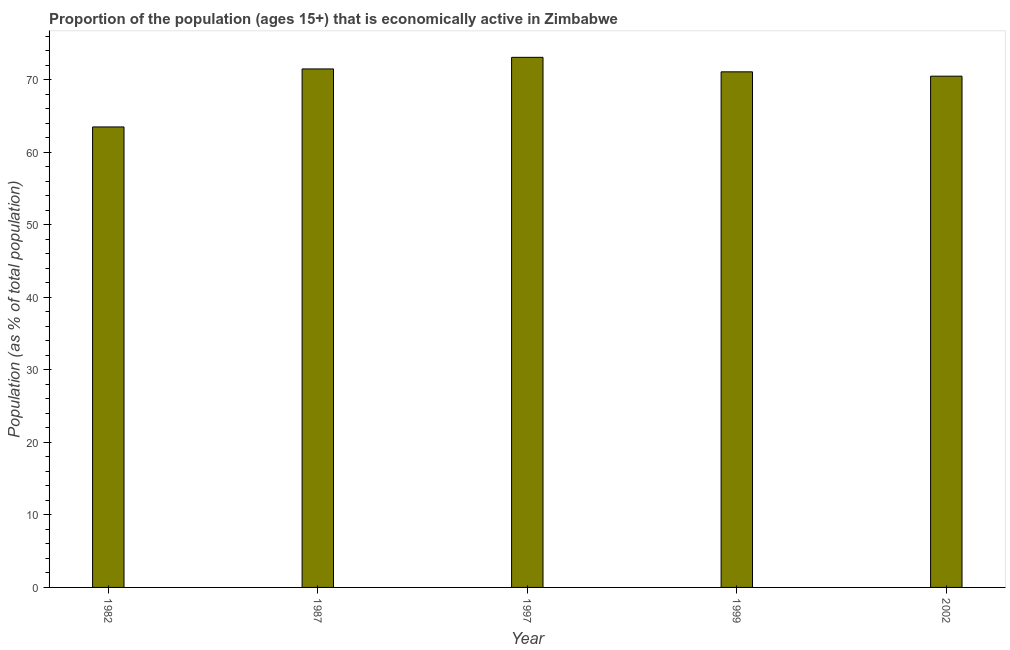What is the title of the graph?
Give a very brief answer. Proportion of the population (ages 15+) that is economically active in Zimbabwe. What is the label or title of the X-axis?
Offer a terse response. Year. What is the label or title of the Y-axis?
Your answer should be very brief. Population (as % of total population). What is the percentage of economically active population in 1987?
Provide a short and direct response. 71.5. Across all years, what is the maximum percentage of economically active population?
Keep it short and to the point. 73.1. Across all years, what is the minimum percentage of economically active population?
Provide a short and direct response. 63.5. In which year was the percentage of economically active population minimum?
Your answer should be compact. 1982. What is the sum of the percentage of economically active population?
Give a very brief answer. 349.7. What is the difference between the percentage of economically active population in 1997 and 1999?
Ensure brevity in your answer.  2. What is the average percentage of economically active population per year?
Keep it short and to the point. 69.94. What is the median percentage of economically active population?
Offer a terse response. 71.1. In how many years, is the percentage of economically active population greater than 22 %?
Make the answer very short. 5. Is the percentage of economically active population in 1987 less than that in 1999?
Offer a very short reply. No. Is the sum of the percentage of economically active population in 1982 and 1999 greater than the maximum percentage of economically active population across all years?
Your answer should be very brief. Yes. What is the Population (as % of total population) of 1982?
Offer a very short reply. 63.5. What is the Population (as % of total population) in 1987?
Offer a very short reply. 71.5. What is the Population (as % of total population) of 1997?
Keep it short and to the point. 73.1. What is the Population (as % of total population) in 1999?
Your answer should be compact. 71.1. What is the Population (as % of total population) of 2002?
Your response must be concise. 70.5. What is the difference between the Population (as % of total population) in 1982 and 1997?
Offer a terse response. -9.6. What is the difference between the Population (as % of total population) in 1982 and 2002?
Give a very brief answer. -7. What is the difference between the Population (as % of total population) in 1987 and 2002?
Your answer should be compact. 1. What is the difference between the Population (as % of total population) in 1997 and 1999?
Ensure brevity in your answer.  2. What is the difference between the Population (as % of total population) in 1997 and 2002?
Your answer should be very brief. 2.6. What is the ratio of the Population (as % of total population) in 1982 to that in 1987?
Give a very brief answer. 0.89. What is the ratio of the Population (as % of total population) in 1982 to that in 1997?
Your answer should be very brief. 0.87. What is the ratio of the Population (as % of total population) in 1982 to that in 1999?
Make the answer very short. 0.89. What is the ratio of the Population (as % of total population) in 1982 to that in 2002?
Offer a very short reply. 0.9. What is the ratio of the Population (as % of total population) in 1987 to that in 1997?
Offer a very short reply. 0.98. What is the ratio of the Population (as % of total population) in 1987 to that in 2002?
Your answer should be compact. 1.01. What is the ratio of the Population (as % of total population) in 1997 to that in 1999?
Offer a terse response. 1.03. What is the ratio of the Population (as % of total population) in 1997 to that in 2002?
Provide a short and direct response. 1.04. 